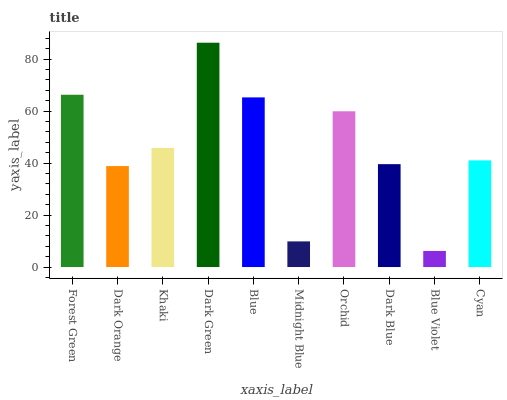Is Blue Violet the minimum?
Answer yes or no. Yes. Is Dark Green the maximum?
Answer yes or no. Yes. Is Dark Orange the minimum?
Answer yes or no. No. Is Dark Orange the maximum?
Answer yes or no. No. Is Forest Green greater than Dark Orange?
Answer yes or no. Yes. Is Dark Orange less than Forest Green?
Answer yes or no. Yes. Is Dark Orange greater than Forest Green?
Answer yes or no. No. Is Forest Green less than Dark Orange?
Answer yes or no. No. Is Khaki the high median?
Answer yes or no. Yes. Is Cyan the low median?
Answer yes or no. Yes. Is Midnight Blue the high median?
Answer yes or no. No. Is Dark Blue the low median?
Answer yes or no. No. 